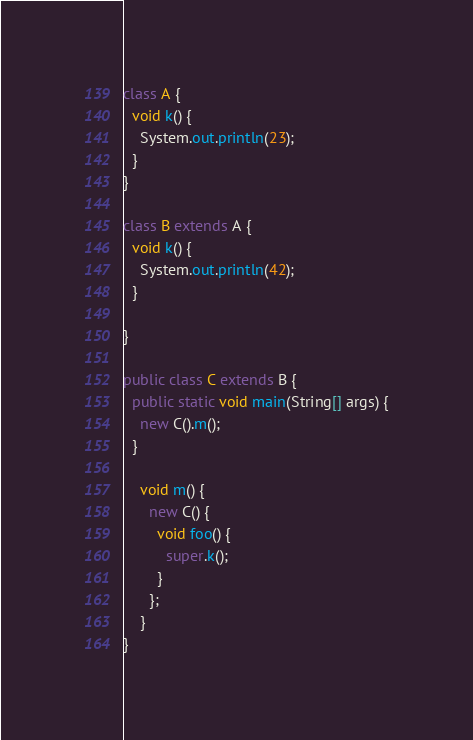<code> <loc_0><loc_0><loc_500><loc_500><_Java_>class A {
  void k() {
    System.out.println(23);
  }
}

class B extends A {
  void k() {
    System.out.println(42);
  }

}

public class C extends B {
  public static void main(String[] args) {
    new C().m();
  }

    void m() {
      new C() {
        void foo() {
          super.k();
        }
      };
    }
}</code> 